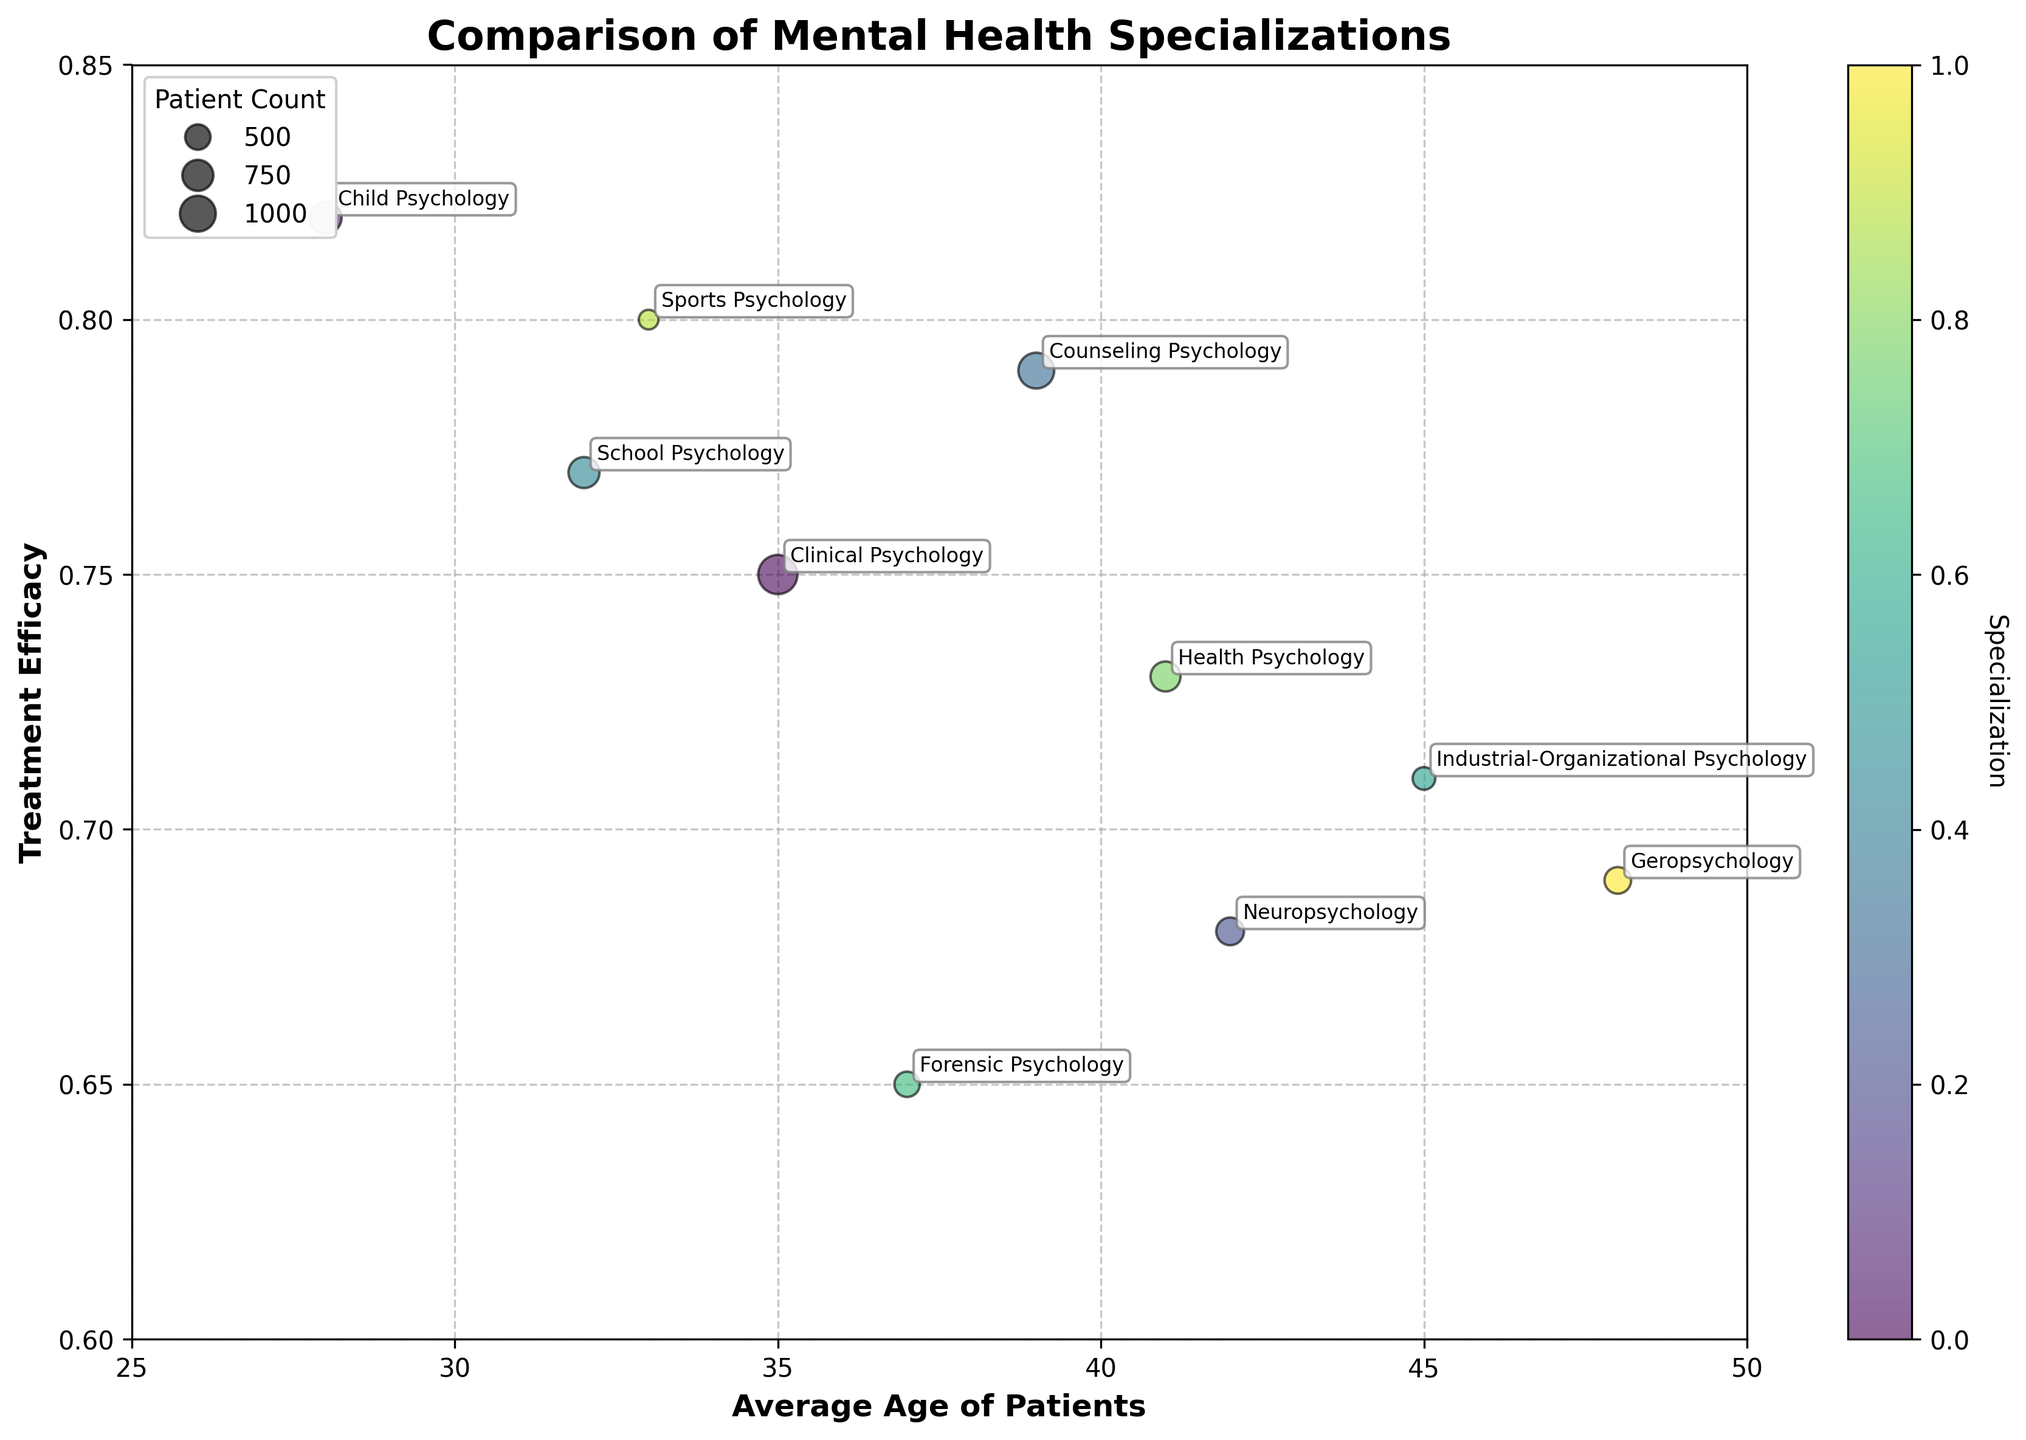What is the title of the figure? The title of the figure is displayed at the top. It is written in bold and larger font size compared to other text elements in the plot.
Answer: Comparison of Mental Health Specializations What is the average age of patients for Clinical Psychology? The average age of patients is shown along the x-axis. For Clinical Psychology, look at the corresponding bubble and read the value on the x-axis.
Answer: 35 Which specialization has the highest treatment efficacy? Treatment efficacy is shown on the y-axis. The highest y-value corresponds to the specialization with the highest treatment efficacy.
Answer: Child Psychology What is the primary patient group for Geropsychology? Each specialization's primary patient group is mentioned in the data and labeled near their respective bubbles. For Geropsychology, the annotation text shows the group.
Answer: Elderly How does the patient count vary across different specializations? The size of each bubble represents the patient count, with larger bubbles indicating higher numbers. Compare the sizes of all the bubbles to see the variation.
Answer: Varies from 300 to 1200 Combine the answers to previous questions to identify the specialization with the highest treatment efficacy and its patient count The specialization with the highest treatment efficacy (Child Psychology) should be identified, and then the patient count for that bubble should be noted from its size indication.
Answer: Child Psychology, 800 Among Clinical Psychology and Counseling Psychology, which has a higher treatment efficacy? Compare the y-values of the bubbles labeled Clinical Psychology and Counseling Psychology. The bubble higher on the y-axis has the higher treatment efficacy.
Answer: Counseling Psychology What is the range of average ages of patients across all specializations? The x-axis shows the range of average ages. Identify the minimum and maximum x-values for all bubbles and calculate the range.
Answer: 28 to 48 Which specializations cater to elderly patients, and what are their treatment efficacies? Look for bubbles labeled with 'Elderly' as the primary patient group, then read their corresponding y-values for treatment efficacy.
Answer: Neuropsychology (0.68) and Geropsychology (0.69) What is the relationship between patient count and bubble size? The legend indicates how the bubble size correlates with patient count. Larger sizes represent higher patient counts, illustrated by the scatterplot.
Answer: Larger bubbles indicate higher patient counts 